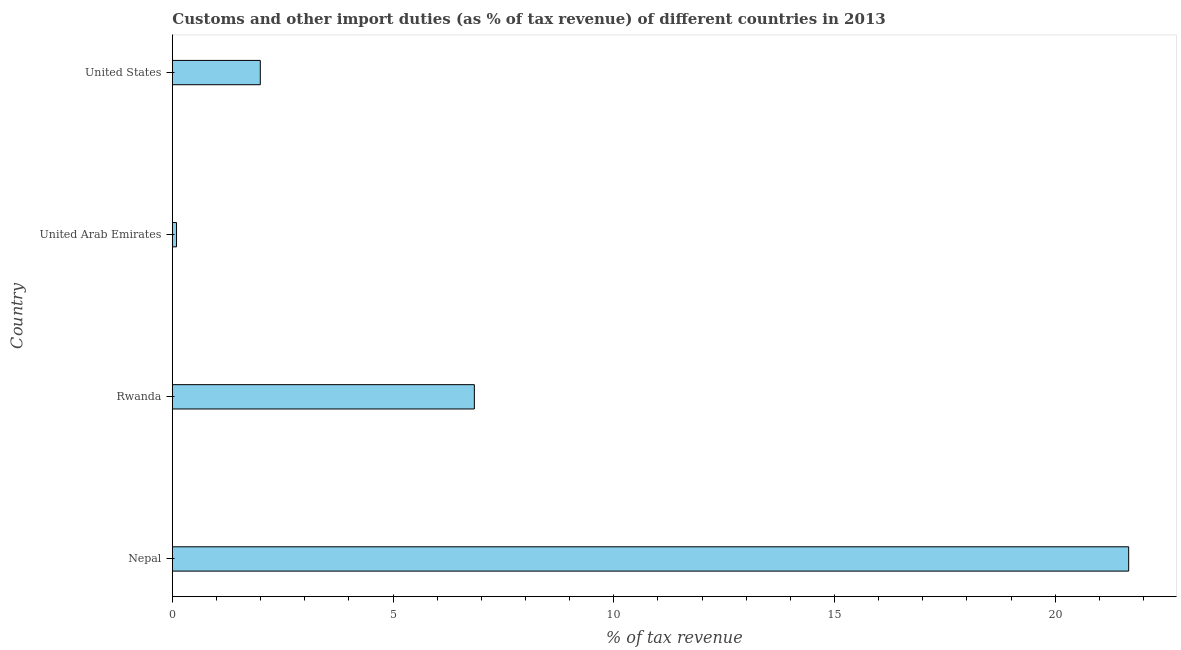Does the graph contain grids?
Provide a succinct answer. No. What is the title of the graph?
Offer a very short reply. Customs and other import duties (as % of tax revenue) of different countries in 2013. What is the label or title of the X-axis?
Make the answer very short. % of tax revenue. What is the label or title of the Y-axis?
Your response must be concise. Country. What is the customs and other import duties in Nepal?
Make the answer very short. 21.67. Across all countries, what is the maximum customs and other import duties?
Offer a terse response. 21.67. Across all countries, what is the minimum customs and other import duties?
Ensure brevity in your answer.  0.09. In which country was the customs and other import duties maximum?
Provide a succinct answer. Nepal. In which country was the customs and other import duties minimum?
Your answer should be very brief. United Arab Emirates. What is the sum of the customs and other import duties?
Make the answer very short. 30.59. What is the difference between the customs and other import duties in Nepal and Rwanda?
Offer a very short reply. 14.82. What is the average customs and other import duties per country?
Provide a succinct answer. 7.65. What is the median customs and other import duties?
Your answer should be very brief. 4.42. What is the ratio of the customs and other import duties in Nepal to that in Rwanda?
Offer a terse response. 3.17. Is the customs and other import duties in Nepal less than that in United Arab Emirates?
Your answer should be compact. No. Is the difference between the customs and other import duties in Rwanda and United Arab Emirates greater than the difference between any two countries?
Your answer should be very brief. No. What is the difference between the highest and the second highest customs and other import duties?
Keep it short and to the point. 14.82. Is the sum of the customs and other import duties in Rwanda and United Arab Emirates greater than the maximum customs and other import duties across all countries?
Keep it short and to the point. No. What is the difference between the highest and the lowest customs and other import duties?
Offer a terse response. 21.57. In how many countries, is the customs and other import duties greater than the average customs and other import duties taken over all countries?
Offer a terse response. 1. How many countries are there in the graph?
Provide a succinct answer. 4. Are the values on the major ticks of X-axis written in scientific E-notation?
Provide a succinct answer. No. What is the % of tax revenue in Nepal?
Provide a short and direct response. 21.67. What is the % of tax revenue of Rwanda?
Make the answer very short. 6.84. What is the % of tax revenue in United Arab Emirates?
Ensure brevity in your answer.  0.09. What is the % of tax revenue in United States?
Provide a succinct answer. 1.99. What is the difference between the % of tax revenue in Nepal and Rwanda?
Offer a terse response. 14.82. What is the difference between the % of tax revenue in Nepal and United Arab Emirates?
Make the answer very short. 21.57. What is the difference between the % of tax revenue in Nepal and United States?
Ensure brevity in your answer.  19.67. What is the difference between the % of tax revenue in Rwanda and United Arab Emirates?
Your answer should be compact. 6.75. What is the difference between the % of tax revenue in Rwanda and United States?
Offer a very short reply. 4.85. What is the difference between the % of tax revenue in United Arab Emirates and United States?
Offer a very short reply. -1.9. What is the ratio of the % of tax revenue in Nepal to that in Rwanda?
Your response must be concise. 3.17. What is the ratio of the % of tax revenue in Nepal to that in United Arab Emirates?
Offer a very short reply. 229.03. What is the ratio of the % of tax revenue in Nepal to that in United States?
Ensure brevity in your answer.  10.87. What is the ratio of the % of tax revenue in Rwanda to that in United Arab Emirates?
Ensure brevity in your answer.  72.33. What is the ratio of the % of tax revenue in Rwanda to that in United States?
Make the answer very short. 3.43. What is the ratio of the % of tax revenue in United Arab Emirates to that in United States?
Your answer should be compact. 0.05. 